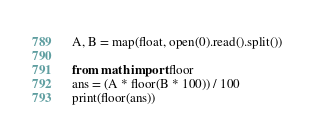<code> <loc_0><loc_0><loc_500><loc_500><_Python_>A, B = map(float, open(0).read().split())

from math import floor
ans = (A * floor(B * 100)) / 100
print(floor(ans))</code> 